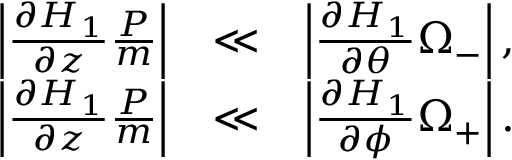Convert formula to latex. <formula><loc_0><loc_0><loc_500><loc_500>\begin{array} { r l r } { \left | \frac { \partial H _ { 1 } } { \partial z } \frac { P } { m } \right | } & { \ll } & { \left | \frac { \partial H _ { 1 } } { \partial \theta } \Omega _ { - } \right | , } \\ { \left | \frac { \partial H _ { 1 } } { \partial z } \frac { P } { m } \right | } & { \ll } & { \left | \frac { \partial H _ { 1 } } { \partial \phi } \Omega _ { + } \right | . } \end{array}</formula> 